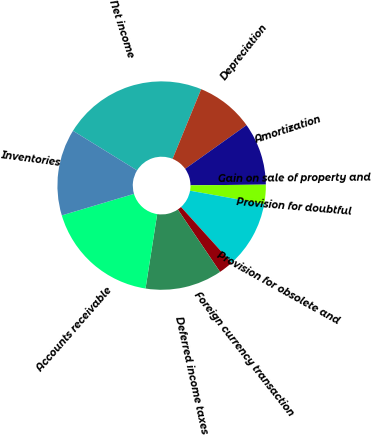Convert chart to OTSL. <chart><loc_0><loc_0><loc_500><loc_500><pie_chart><fcel>Net income<fcel>Depreciation<fcel>Amortization<fcel>Gain on sale of property and<fcel>Provision for doubtful<fcel>Provision for obsolete and<fcel>Foreign currency transaction<fcel>Deferred income taxes<fcel>Accounts receivable<fcel>Inventories<nl><fcel>22.39%<fcel>8.96%<fcel>9.7%<fcel>0.0%<fcel>2.99%<fcel>10.45%<fcel>2.24%<fcel>11.94%<fcel>17.91%<fcel>13.43%<nl></chart> 